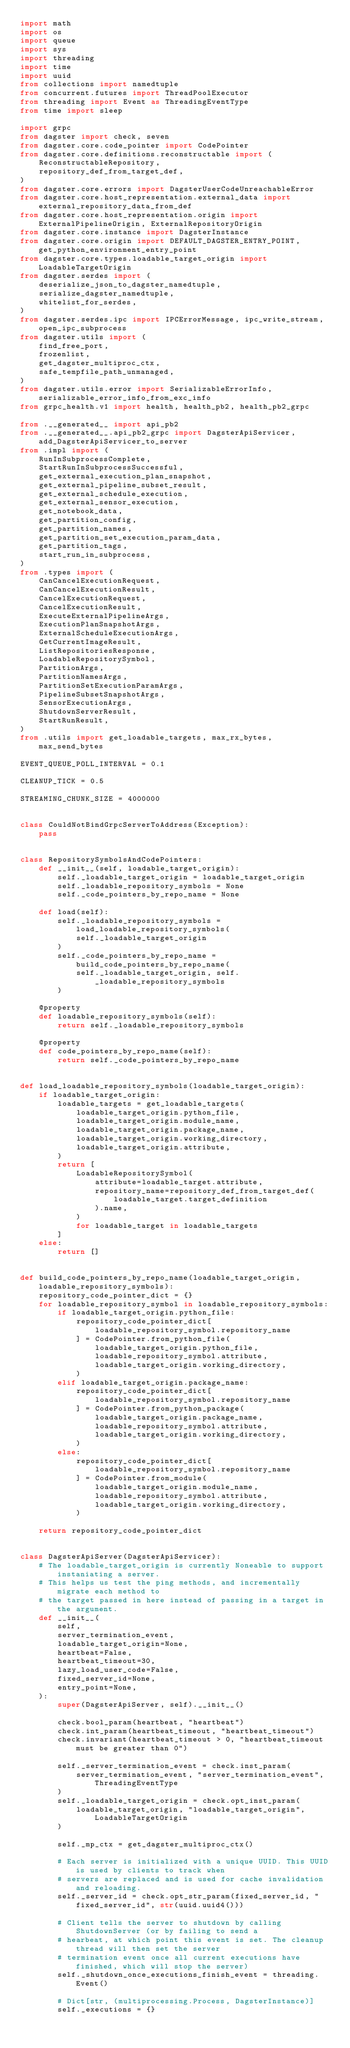<code> <loc_0><loc_0><loc_500><loc_500><_Python_>import math
import os
import queue
import sys
import threading
import time
import uuid
from collections import namedtuple
from concurrent.futures import ThreadPoolExecutor
from threading import Event as ThreadingEventType
from time import sleep

import grpc
from dagster import check, seven
from dagster.core.code_pointer import CodePointer
from dagster.core.definitions.reconstructable import (
    ReconstructableRepository,
    repository_def_from_target_def,
)
from dagster.core.errors import DagsterUserCodeUnreachableError
from dagster.core.host_representation.external_data import external_repository_data_from_def
from dagster.core.host_representation.origin import ExternalPipelineOrigin, ExternalRepositoryOrigin
from dagster.core.instance import DagsterInstance
from dagster.core.origin import DEFAULT_DAGSTER_ENTRY_POINT, get_python_environment_entry_point
from dagster.core.types.loadable_target_origin import LoadableTargetOrigin
from dagster.serdes import (
    deserialize_json_to_dagster_namedtuple,
    serialize_dagster_namedtuple,
    whitelist_for_serdes,
)
from dagster.serdes.ipc import IPCErrorMessage, ipc_write_stream, open_ipc_subprocess
from dagster.utils import (
    find_free_port,
    frozenlist,
    get_dagster_multiproc_ctx,
    safe_tempfile_path_unmanaged,
)
from dagster.utils.error import SerializableErrorInfo, serializable_error_info_from_exc_info
from grpc_health.v1 import health, health_pb2, health_pb2_grpc

from .__generated__ import api_pb2
from .__generated__.api_pb2_grpc import DagsterApiServicer, add_DagsterApiServicer_to_server
from .impl import (
    RunInSubprocessComplete,
    StartRunInSubprocessSuccessful,
    get_external_execution_plan_snapshot,
    get_external_pipeline_subset_result,
    get_external_schedule_execution,
    get_external_sensor_execution,
    get_notebook_data,
    get_partition_config,
    get_partition_names,
    get_partition_set_execution_param_data,
    get_partition_tags,
    start_run_in_subprocess,
)
from .types import (
    CanCancelExecutionRequest,
    CanCancelExecutionResult,
    CancelExecutionRequest,
    CancelExecutionResult,
    ExecuteExternalPipelineArgs,
    ExecutionPlanSnapshotArgs,
    ExternalScheduleExecutionArgs,
    GetCurrentImageResult,
    ListRepositoriesResponse,
    LoadableRepositorySymbol,
    PartitionArgs,
    PartitionNamesArgs,
    PartitionSetExecutionParamArgs,
    PipelineSubsetSnapshotArgs,
    SensorExecutionArgs,
    ShutdownServerResult,
    StartRunResult,
)
from .utils import get_loadable_targets, max_rx_bytes, max_send_bytes

EVENT_QUEUE_POLL_INTERVAL = 0.1

CLEANUP_TICK = 0.5

STREAMING_CHUNK_SIZE = 4000000


class CouldNotBindGrpcServerToAddress(Exception):
    pass


class RepositorySymbolsAndCodePointers:
    def __init__(self, loadable_target_origin):
        self._loadable_target_origin = loadable_target_origin
        self._loadable_repository_symbols = None
        self._code_pointers_by_repo_name = None

    def load(self):
        self._loadable_repository_symbols = load_loadable_repository_symbols(
            self._loadable_target_origin
        )
        self._code_pointers_by_repo_name = build_code_pointers_by_repo_name(
            self._loadable_target_origin, self._loadable_repository_symbols
        )

    @property
    def loadable_repository_symbols(self):
        return self._loadable_repository_symbols

    @property
    def code_pointers_by_repo_name(self):
        return self._code_pointers_by_repo_name


def load_loadable_repository_symbols(loadable_target_origin):
    if loadable_target_origin:
        loadable_targets = get_loadable_targets(
            loadable_target_origin.python_file,
            loadable_target_origin.module_name,
            loadable_target_origin.package_name,
            loadable_target_origin.working_directory,
            loadable_target_origin.attribute,
        )
        return [
            LoadableRepositorySymbol(
                attribute=loadable_target.attribute,
                repository_name=repository_def_from_target_def(
                    loadable_target.target_definition
                ).name,
            )
            for loadable_target in loadable_targets
        ]
    else:
        return []


def build_code_pointers_by_repo_name(loadable_target_origin, loadable_repository_symbols):
    repository_code_pointer_dict = {}
    for loadable_repository_symbol in loadable_repository_symbols:
        if loadable_target_origin.python_file:
            repository_code_pointer_dict[
                loadable_repository_symbol.repository_name
            ] = CodePointer.from_python_file(
                loadable_target_origin.python_file,
                loadable_repository_symbol.attribute,
                loadable_target_origin.working_directory,
            )
        elif loadable_target_origin.package_name:
            repository_code_pointer_dict[
                loadable_repository_symbol.repository_name
            ] = CodePointer.from_python_package(
                loadable_target_origin.package_name,
                loadable_repository_symbol.attribute,
                loadable_target_origin.working_directory,
            )
        else:
            repository_code_pointer_dict[
                loadable_repository_symbol.repository_name
            ] = CodePointer.from_module(
                loadable_target_origin.module_name,
                loadable_repository_symbol.attribute,
                loadable_target_origin.working_directory,
            )

    return repository_code_pointer_dict


class DagsterApiServer(DagsterApiServicer):
    # The loadable_target_origin is currently Noneable to support instaniating a server.
    # This helps us test the ping methods, and incrementally migrate each method to
    # the target passed in here instead of passing in a target in the argument.
    def __init__(
        self,
        server_termination_event,
        loadable_target_origin=None,
        heartbeat=False,
        heartbeat_timeout=30,
        lazy_load_user_code=False,
        fixed_server_id=None,
        entry_point=None,
    ):
        super(DagsterApiServer, self).__init__()

        check.bool_param(heartbeat, "heartbeat")
        check.int_param(heartbeat_timeout, "heartbeat_timeout")
        check.invariant(heartbeat_timeout > 0, "heartbeat_timeout must be greater than 0")

        self._server_termination_event = check.inst_param(
            server_termination_event, "server_termination_event", ThreadingEventType
        )
        self._loadable_target_origin = check.opt_inst_param(
            loadable_target_origin, "loadable_target_origin", LoadableTargetOrigin
        )

        self._mp_ctx = get_dagster_multiproc_ctx()

        # Each server is initialized with a unique UUID. This UUID is used by clients to track when
        # servers are replaced and is used for cache invalidation and reloading.
        self._server_id = check.opt_str_param(fixed_server_id, "fixed_server_id", str(uuid.uuid4()))

        # Client tells the server to shutdown by calling ShutdownServer (or by failing to send a
        # hearbeat, at which point this event is set. The cleanup thread will then set the server
        # termination event once all current executions have finished, which will stop the server)
        self._shutdown_once_executions_finish_event = threading.Event()

        # Dict[str, (multiprocessing.Process, DagsterInstance)]
        self._executions = {}</code> 